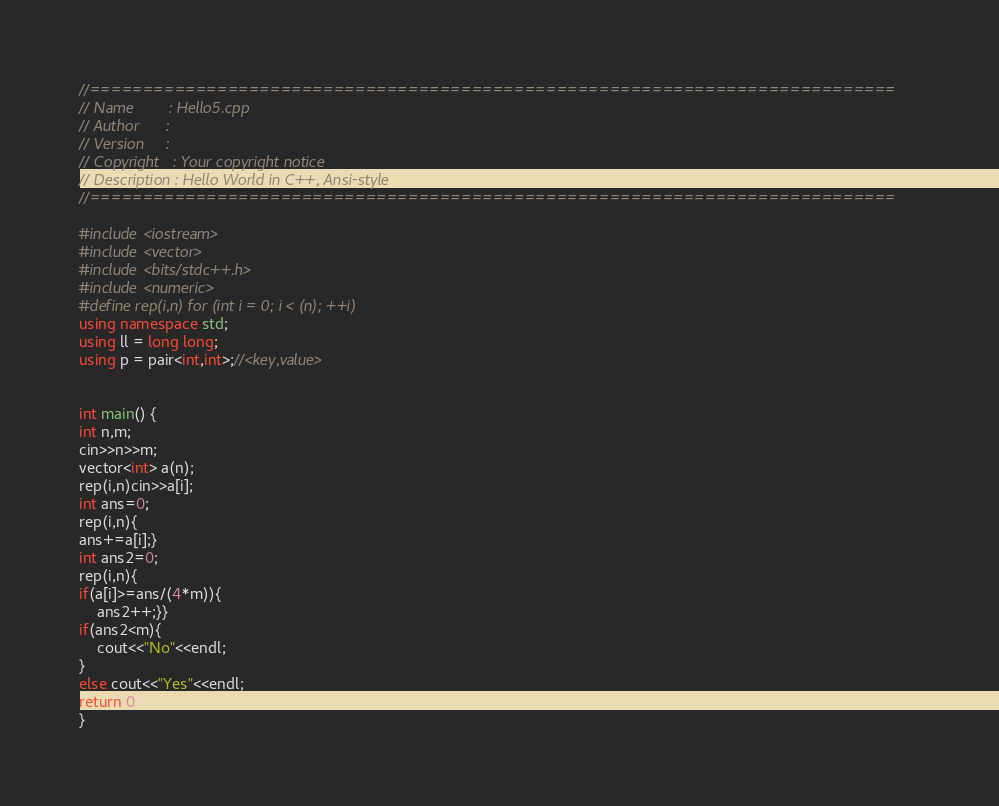Convert code to text. <code><loc_0><loc_0><loc_500><loc_500><_C++_>//============================================================================
// Name        : Hello5.cpp
// Author      :
// Version     :
// Copyright   : Your copyright notice
// Description : Hello World in C++, Ansi-style
//============================================================================

#include <iostream>
#include <vector>
#include <bits/stdc++.h>
#include <numeric>
#define rep(i,n) for (int i = 0; i < (n); ++i)
using namespace std;
using ll = long long;
using p = pair<int,int>;//<key,value>


int main() {
int n,m;
cin>>n>>m;
vector<int> a(n);
rep(i,n)cin>>a[i];
int ans=0;
rep(i,n){
ans+=a[i];}
int ans2=0;
rep(i,n){
if(a[i]>=ans/(4*m)){
	ans2++;}}
if(ans2<m){
	cout<<"No"<<endl;
}
else cout<<"Yes"<<endl;
return 0;
}


</code> 